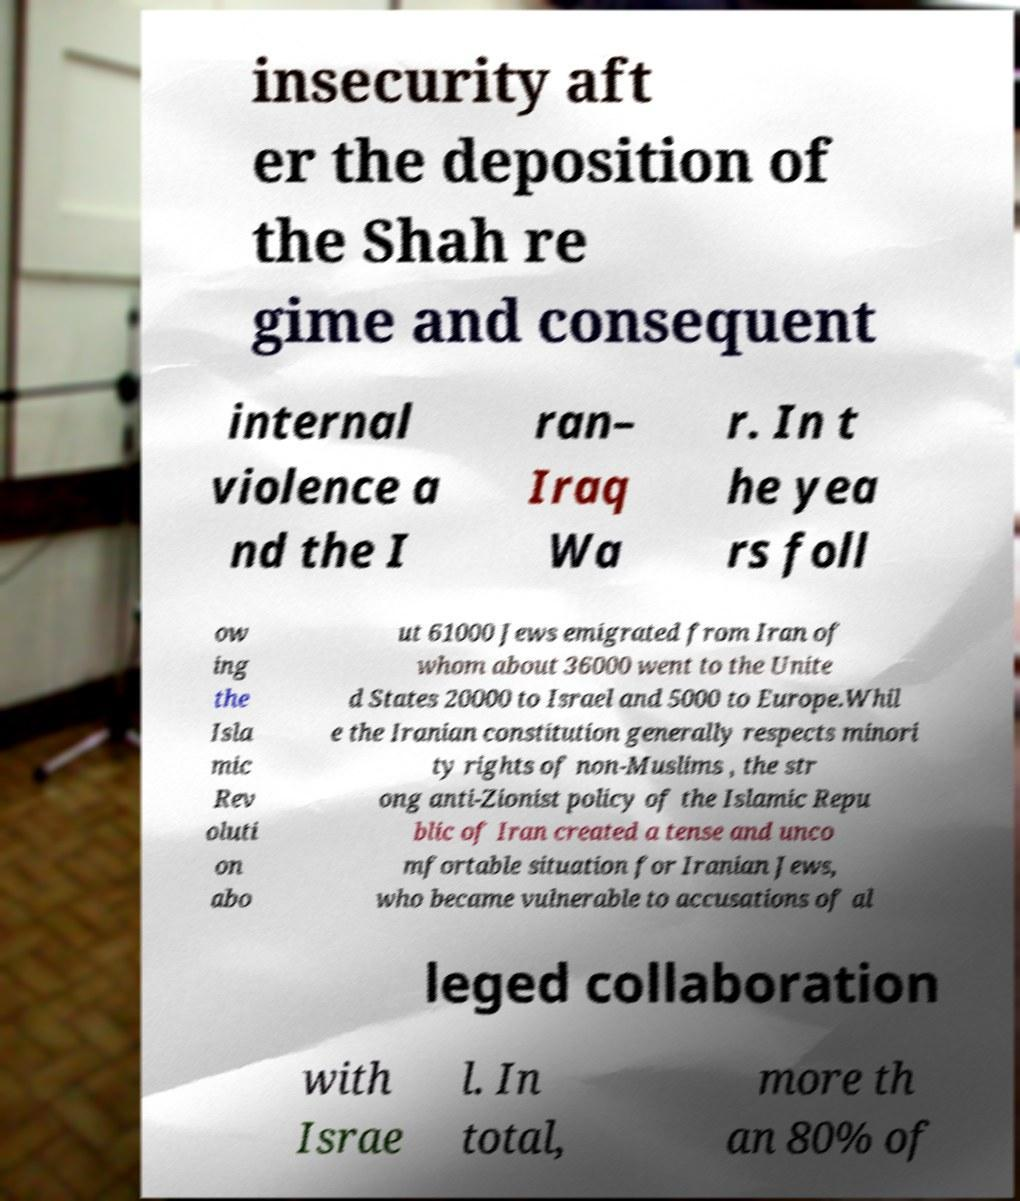Please identify and transcribe the text found in this image. insecurity aft er the deposition of the Shah re gime and consequent internal violence a nd the I ran– Iraq Wa r. In t he yea rs foll ow ing the Isla mic Rev oluti on abo ut 61000 Jews emigrated from Iran of whom about 36000 went to the Unite d States 20000 to Israel and 5000 to Europe.Whil e the Iranian constitution generally respects minori ty rights of non-Muslims , the str ong anti-Zionist policy of the Islamic Repu blic of Iran created a tense and unco mfortable situation for Iranian Jews, who became vulnerable to accusations of al leged collaboration with Israe l. In total, more th an 80% of 